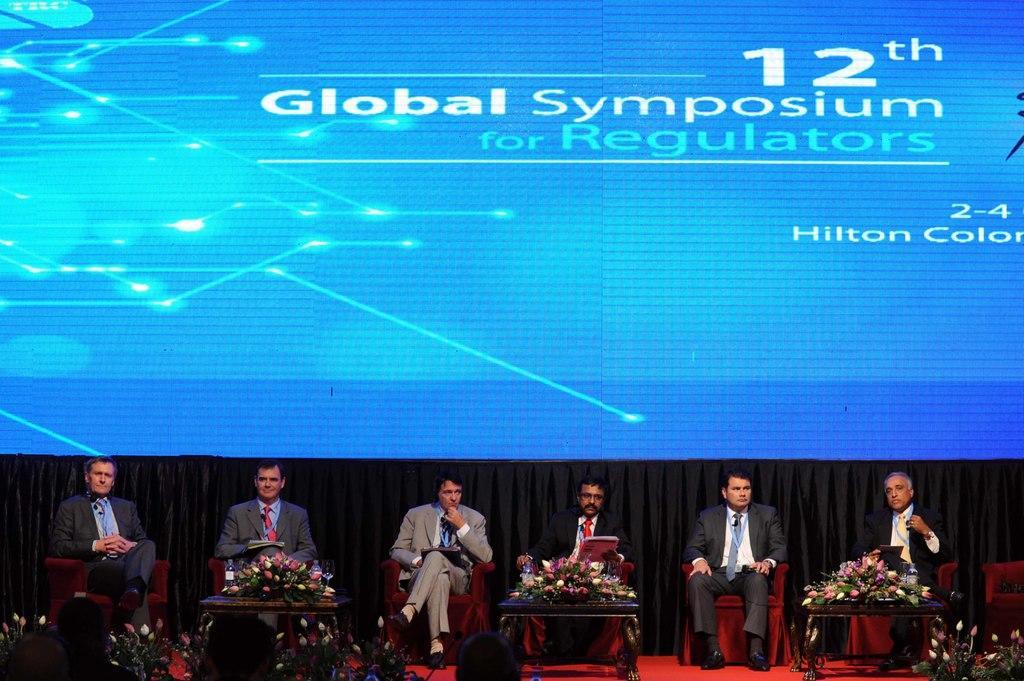Could you give a brief overview of what you see in this image? In the picture it is a press meet some people are sitting on the chairs on stage there are flower bouquets in front of them, in the background there is a huge presentation screen and it is displaying "Global symposium for regulators" on the screen. 